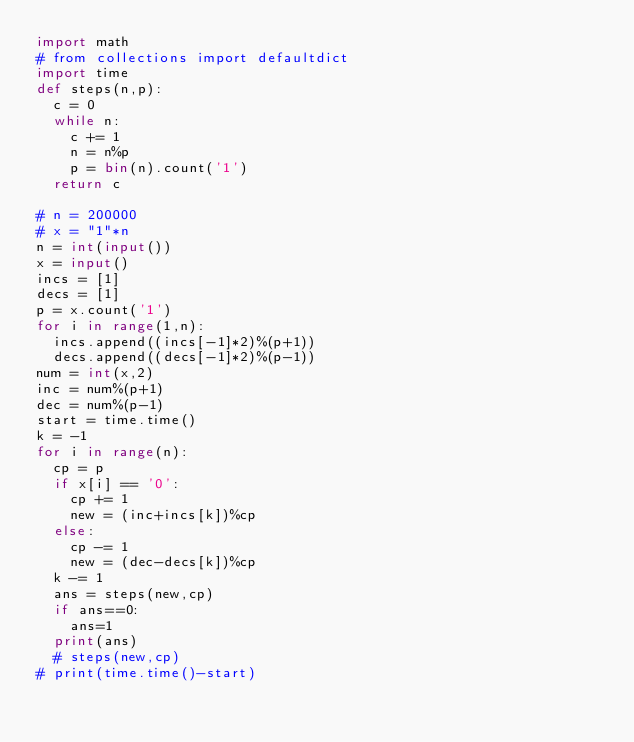<code> <loc_0><loc_0><loc_500><loc_500><_Python_>import math
# from collections import defaultdict
import time
def steps(n,p):
  c = 0
  while n:
    c += 1
    n = n%p
    p = bin(n).count('1')
  return c

# n = 200000
# x = "1"*n
n = int(input())
x = input()
incs = [1]
decs = [1]
p = x.count('1')
for i in range(1,n):
  incs.append((incs[-1]*2)%(p+1))
  decs.append((decs[-1]*2)%(p-1))
num = int(x,2)
inc = num%(p+1)
dec = num%(p-1)
start = time.time()
k = -1
for i in range(n):
  cp = p
  if x[i] == '0':
    cp += 1
    new = (inc+incs[k])%cp
  else:
    cp -= 1
    new = (dec-decs[k])%cp
  k -= 1
  ans = steps(new,cp)
  if ans==0:
    ans=1
  print(ans)
  # steps(new,cp)
# print(time.time()-start)</code> 